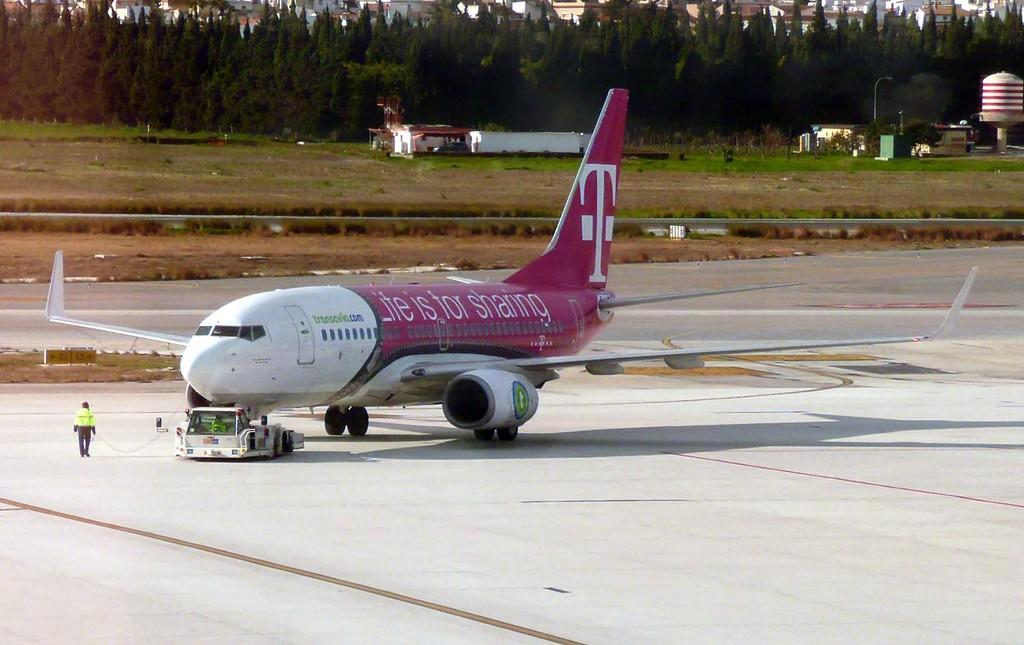<image>
Give a short and clear explanation of the subsequent image. Transavia.com logo and Lite is for sharing logo for T mobile on a airplane. 